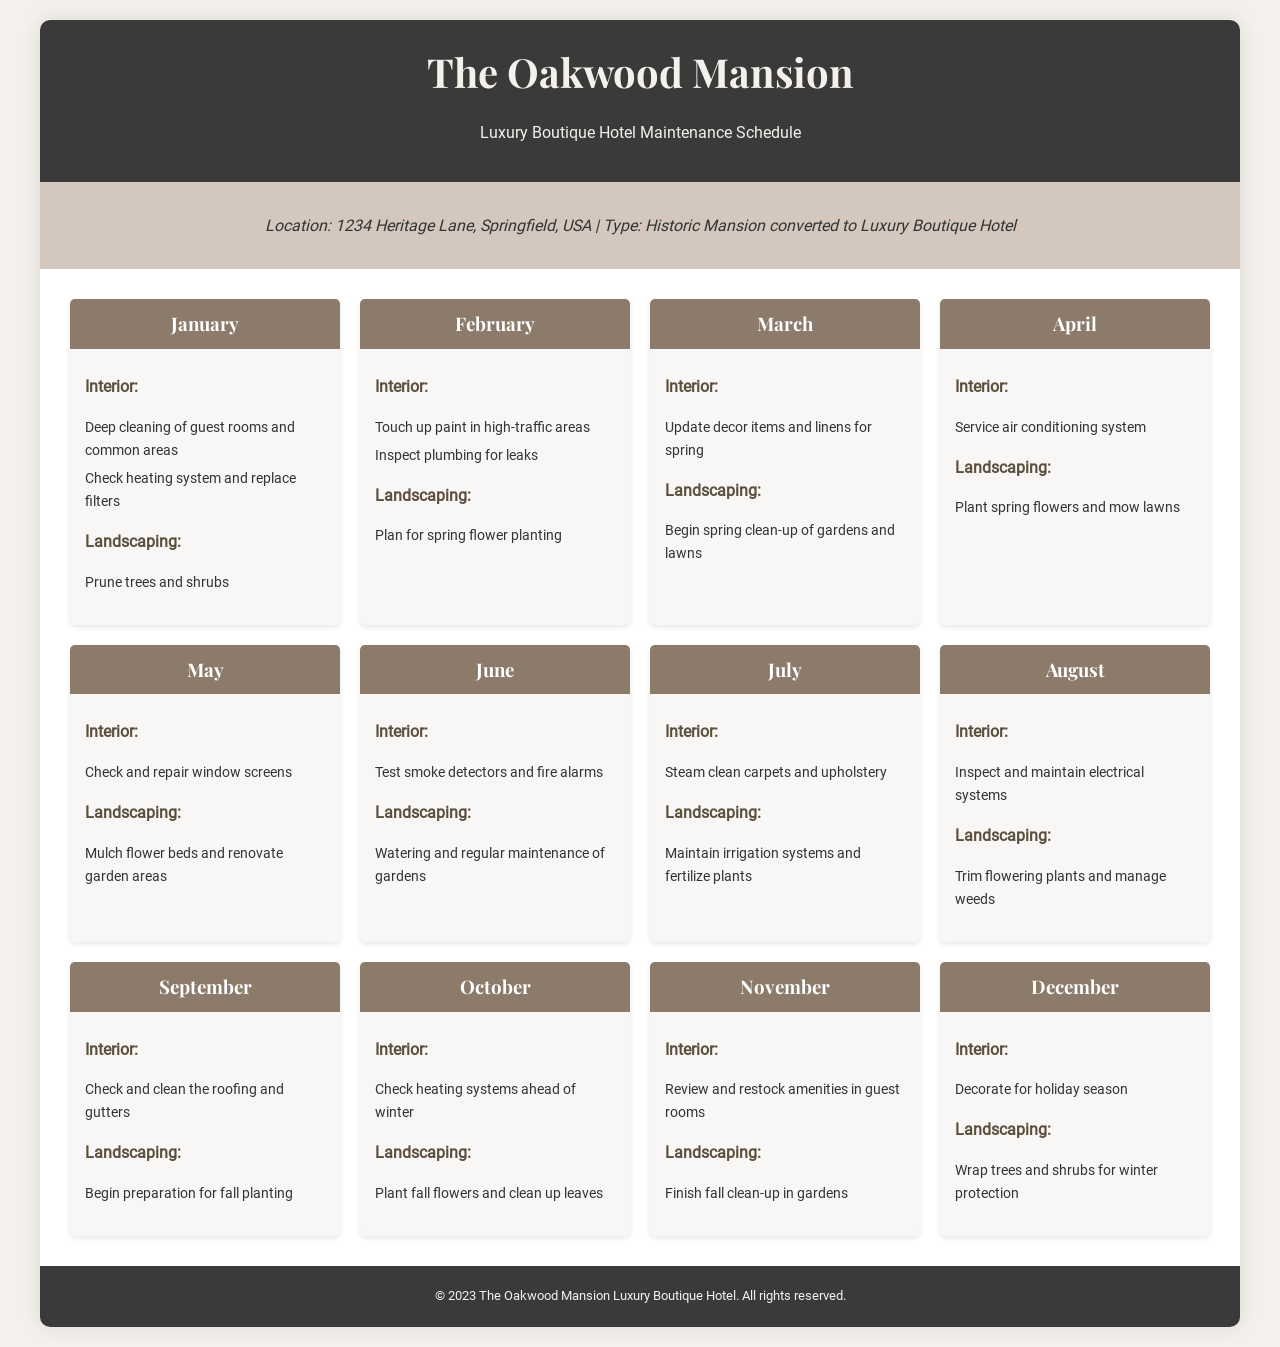what is the location of the mansion? The location of the mansion is specified in the property information section of the document.
Answer: 1234 Heritage Lane, Springfield, USA which month has deep cleaning of guest rooms and common areas? The task of deep cleaning guest rooms and common areas is listed under January in the maintenance schedule.
Answer: January how many tasks are listed for February? February has two interior tasks and one landscaping task, totaling three tasks.
Answer: Three what is the main task in June for landscaping? The main landscaping task in June is found in the month content of the schedule.
Answer: Watering and regular maintenance of gardens which month includes preparing for fall planting? The preparation for fall planting is specifically noted in the landscaping section for September.
Answer: September what activity is recommended in October for landscaping? The landscaping activity for October includes a specific task mentioned in that month’s content.
Answer: Plant fall flowers and clean up leaves which system is checked and repaired in August? The document states the task of inspecting and maintaining an essential system in August.
Answer: Electrical systems how many months mention tasks related to winter preparation? Both December and October contain tasks related to winter preparation in the document.
Answer: Two what type of cleaning is scheduled for July? The scheduled cleaning task for July is detailed under the interior maintenance tasks.
Answer: Steam clean carpets and upholstery 